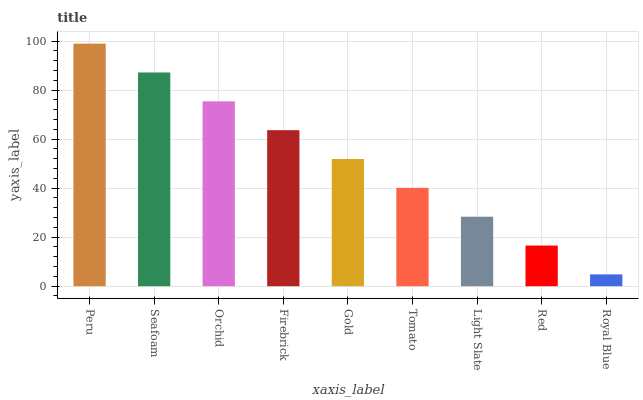Is Royal Blue the minimum?
Answer yes or no. Yes. Is Peru the maximum?
Answer yes or no. Yes. Is Seafoam the minimum?
Answer yes or no. No. Is Seafoam the maximum?
Answer yes or no. No. Is Peru greater than Seafoam?
Answer yes or no. Yes. Is Seafoam less than Peru?
Answer yes or no. Yes. Is Seafoam greater than Peru?
Answer yes or no. No. Is Peru less than Seafoam?
Answer yes or no. No. Is Gold the high median?
Answer yes or no. Yes. Is Gold the low median?
Answer yes or no. Yes. Is Red the high median?
Answer yes or no. No. Is Firebrick the low median?
Answer yes or no. No. 